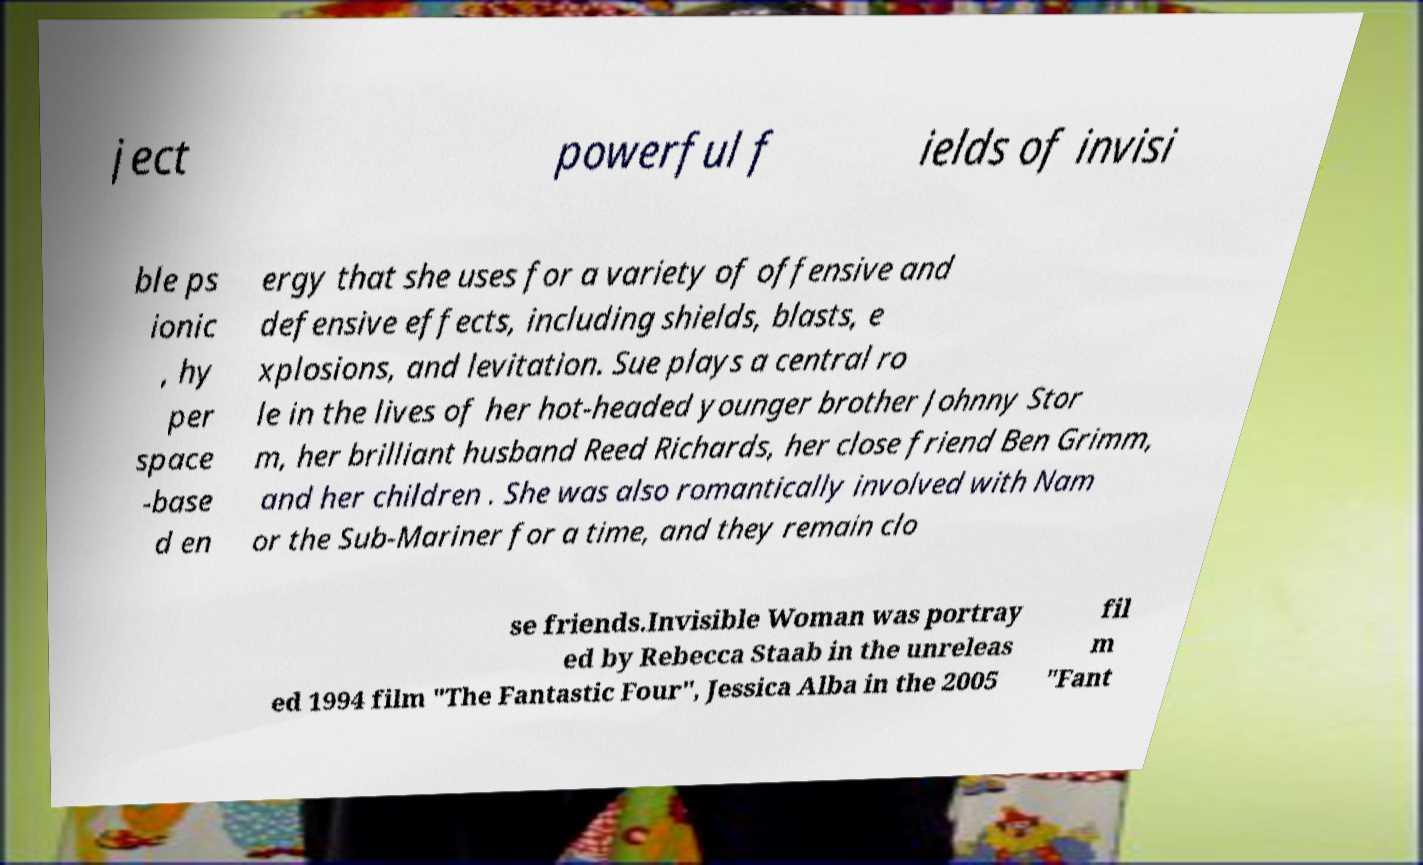Can you accurately transcribe the text from the provided image for me? ject powerful f ields of invisi ble ps ionic , hy per space -base d en ergy that she uses for a variety of offensive and defensive effects, including shields, blasts, e xplosions, and levitation. Sue plays a central ro le in the lives of her hot-headed younger brother Johnny Stor m, her brilliant husband Reed Richards, her close friend Ben Grimm, and her children . She was also romantically involved with Nam or the Sub-Mariner for a time, and they remain clo se friends.Invisible Woman was portray ed by Rebecca Staab in the unreleas ed 1994 film "The Fantastic Four", Jessica Alba in the 2005 fil m "Fant 